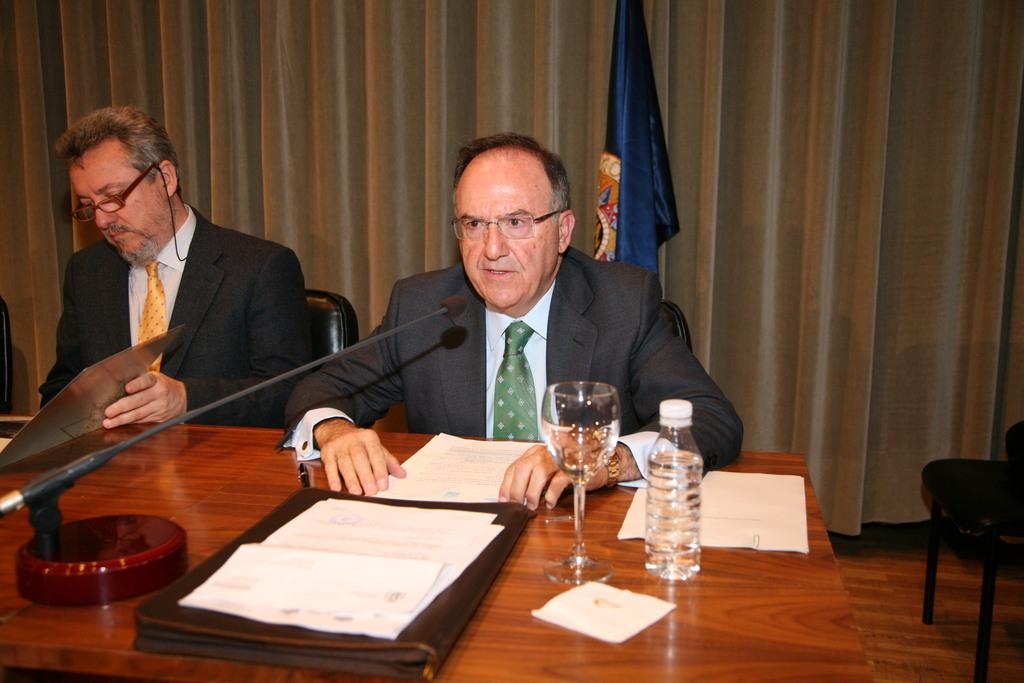How many people are sitting in the image? There are two persons sitting in the image. What is present on the table in the image? There are files, papers, a glass, a bottle, another chair, a flag, and a microphone on the table. What can be seen in the background of the image? There is a curtain in the image. Can you see any goldfish swimming in the image? There are no goldfish present in the image. Are there any lizards crawling on the table in the image? There are no lizards present in the image. 